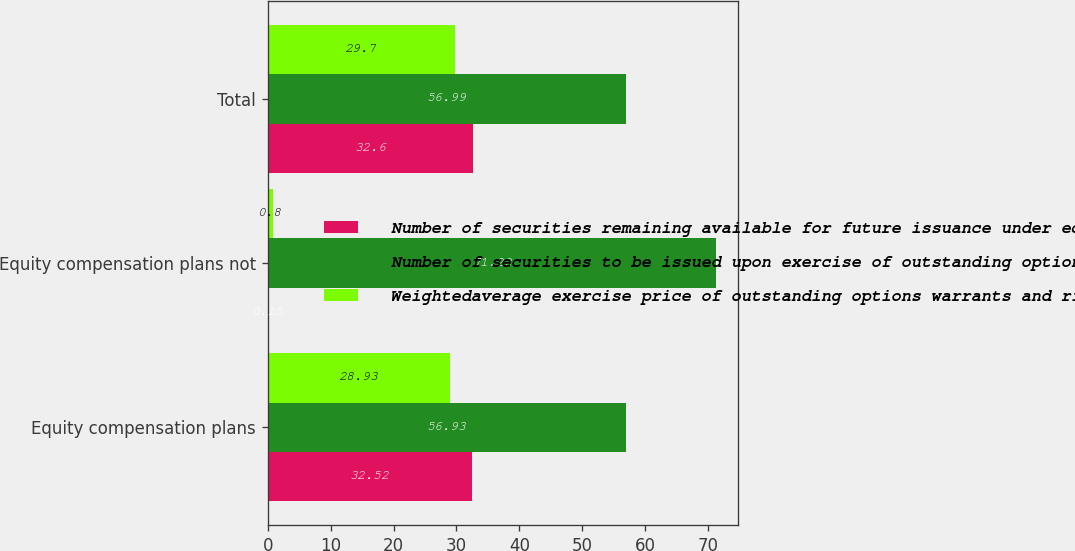Convert chart to OTSL. <chart><loc_0><loc_0><loc_500><loc_500><stacked_bar_chart><ecel><fcel>Equity compensation plans<fcel>Equity compensation plans not<fcel>Total<nl><fcel>Number of securities remaining available for future issuance under equity compensation plans excluding securities reflected in column a in millions c<fcel>32.52<fcel>0.15<fcel>32.6<nl><fcel>Number of securities to be issued upon exercise of outstanding options warrants and rights in millions a<fcel>56.93<fcel>71.22<fcel>56.99<nl><fcel>Weightedaverage exercise price of outstanding options warrants and rights b<fcel>28.93<fcel>0.8<fcel>29.7<nl></chart> 